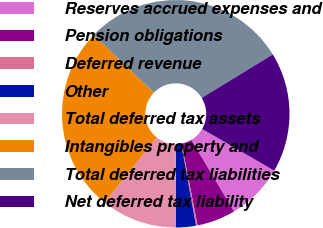Convert chart. <chart><loc_0><loc_0><loc_500><loc_500><pie_chart><fcel>Reserves accrued expenses and<fcel>Pension obligations<fcel>Deferred revenue<fcel>Other<fcel>Total deferred tax assets<fcel>Intangibles property and<fcel>Total deferred tax liabilities<fcel>Net deferred tax liability<nl><fcel>8.11%<fcel>5.48%<fcel>0.23%<fcel>2.86%<fcel>10.74%<fcel>26.44%<fcel>29.07%<fcel>17.06%<nl></chart> 